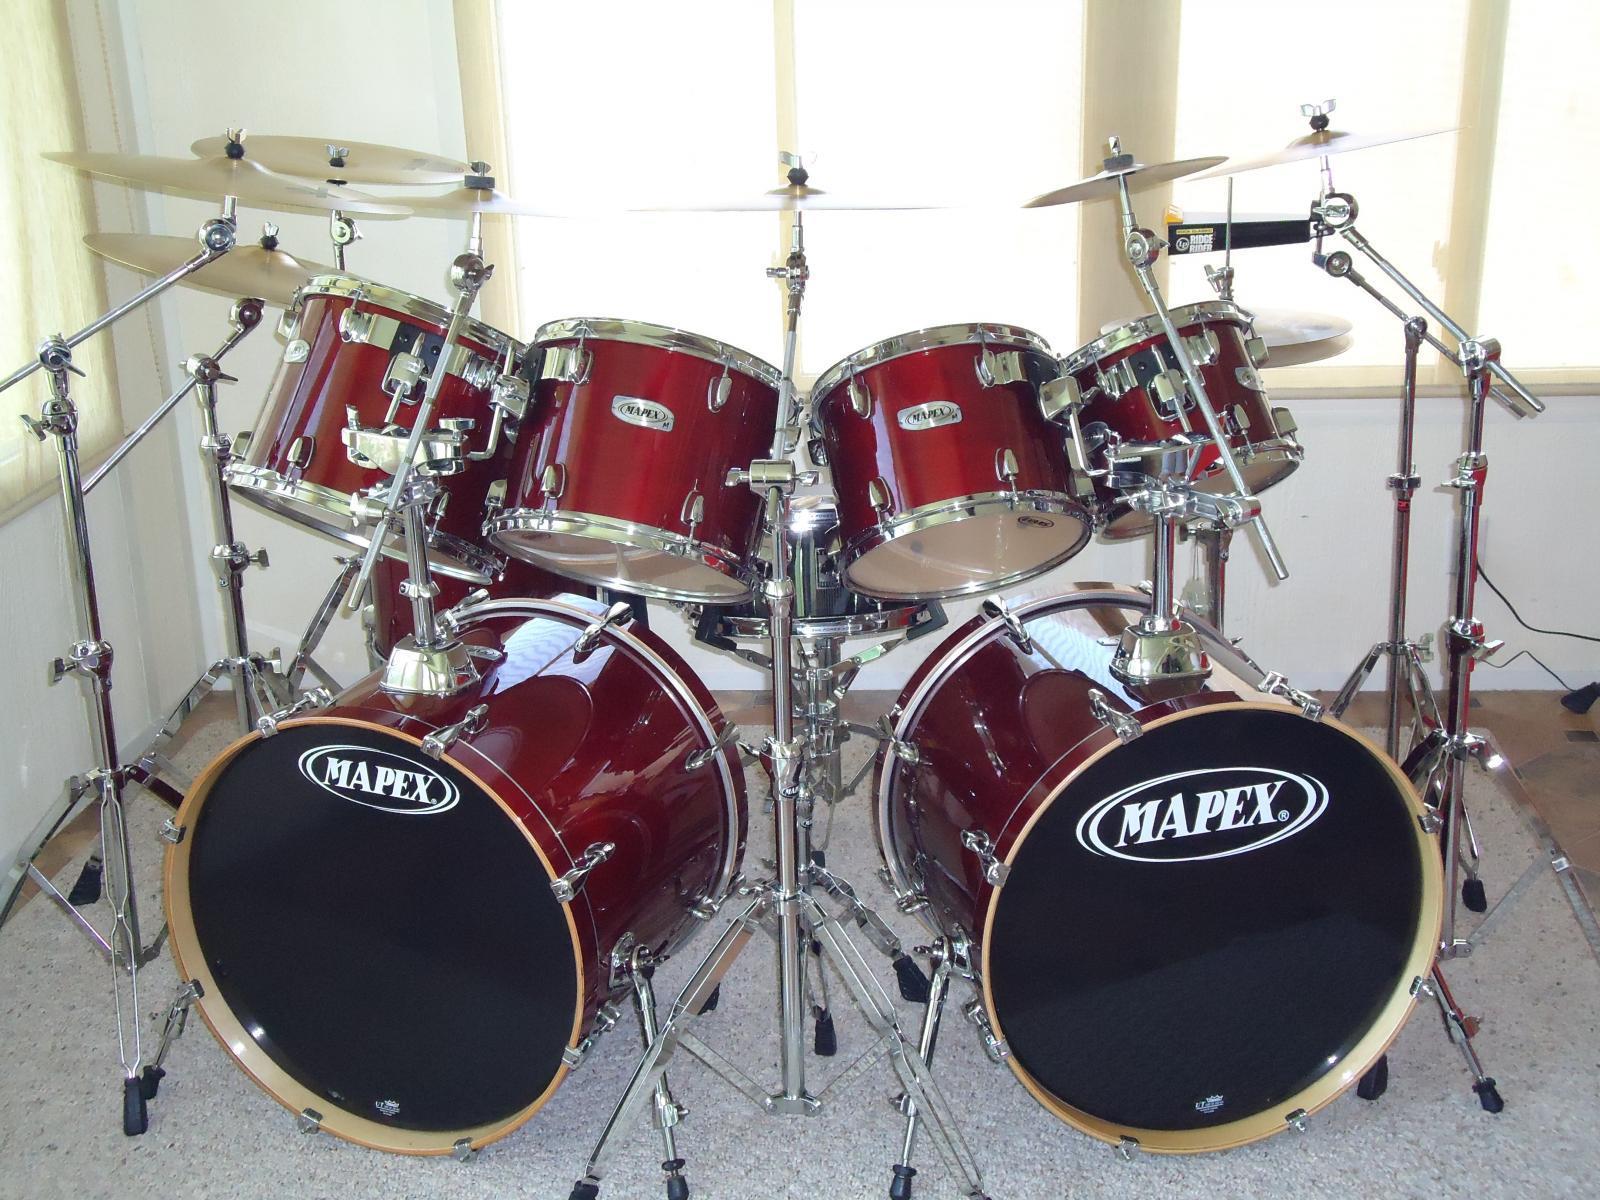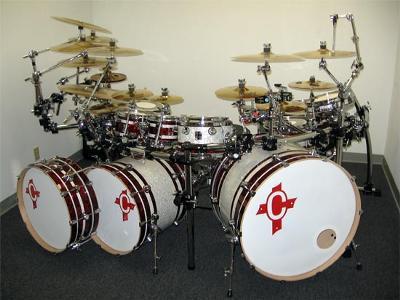The first image is the image on the left, the second image is the image on the right. Evaluate the accuracy of this statement regarding the images: "One of the images is taken from behind a single drum kit.". Is it true? Answer yes or no. No. 